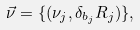<formula> <loc_0><loc_0><loc_500><loc_500>\vec { \nu } = \{ ( \nu _ { j } , \delta _ { b _ { j } } R _ { j } ) \} ,</formula> 